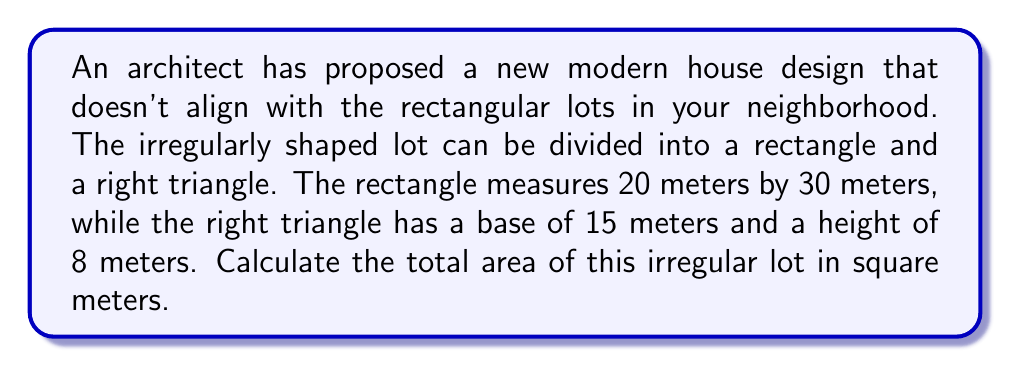Solve this math problem. To calculate the total area of the irregular lot, we need to:

1. Calculate the area of the rectangular portion:
   $$A_{rectangle} = length \times width$$
   $$A_{rectangle} = 20 \text{ m} \times 30 \text{ m} = 600 \text{ m}^2$$

2. Calculate the area of the right triangular portion:
   $$A_{triangle} = \frac{1}{2} \times base \times height$$
   $$A_{triangle} = \frac{1}{2} \times 15 \text{ m} \times 8 \text{ m} = 60 \text{ m}^2$$

3. Sum the areas of both portions:
   $$A_{total} = A_{rectangle} + A_{triangle}$$
   $$A_{total} = 600 \text{ m}^2 + 60 \text{ m}^2 = 660 \text{ m}^2$$

[asy]
unitsize(0.1cm);
fill((0,0)--(30,0)--(30,20)--(45,20)--(45,28)--(0,28)--cycle, lightgray);
draw((0,0)--(30,0)--(30,20)--(45,20)--(45,28)--(0,28)--cycle);
draw((30,20)--(30,28));
label("30 m", (15,0), S);
label("20 m", (0,10), W);
label("15 m", (37.5,20), S);
label("8 m", (45,24), E);
[/asy]
Answer: 660 m² 